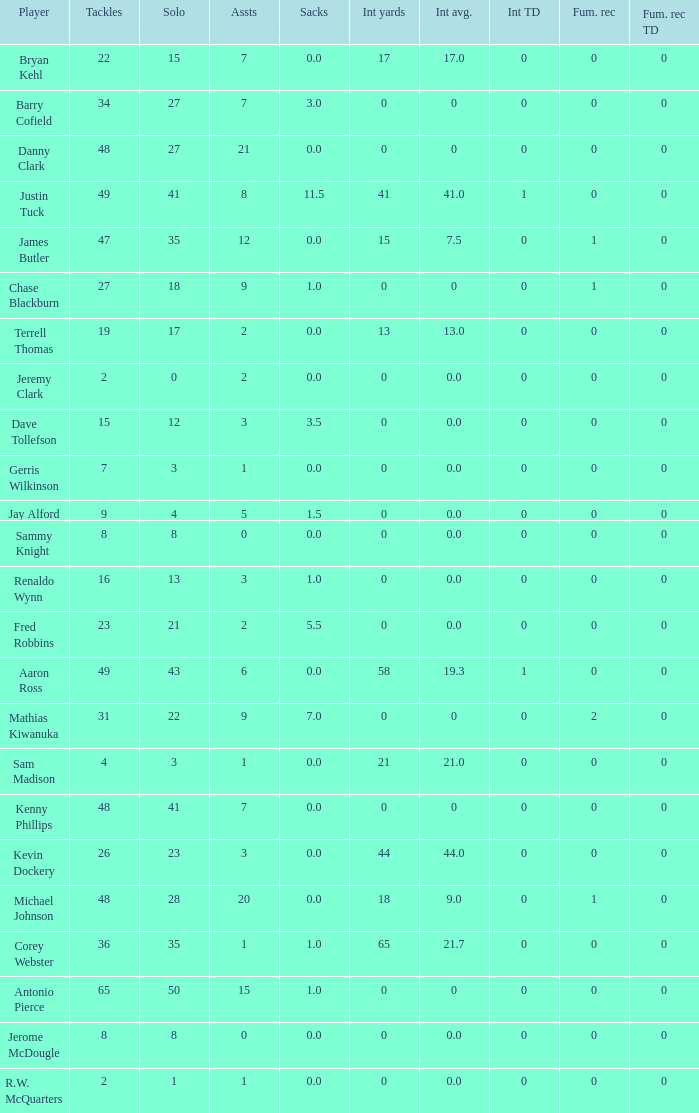What is the sum for the int yards that has an assts more than 3, and player Jay Alford? 0.0. 